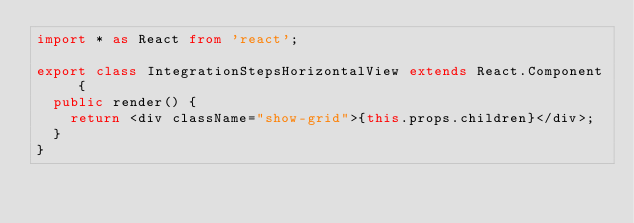Convert code to text. <code><loc_0><loc_0><loc_500><loc_500><_TypeScript_>import * as React from 'react';

export class IntegrationStepsHorizontalView extends React.Component {
  public render() {
    return <div className="show-grid">{this.props.children}</div>;
  }
}
</code> 